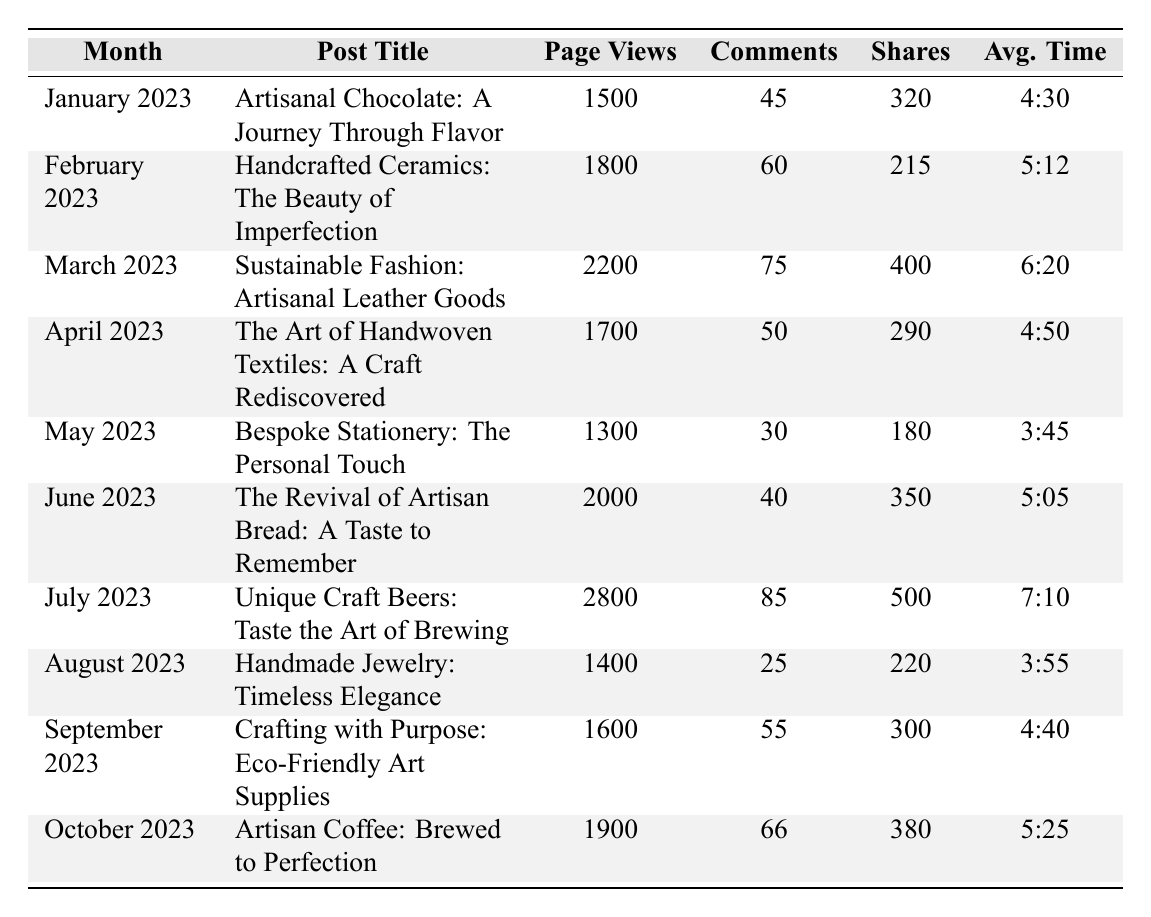What was the post with the highest page views? The post with the highest page views is "Unique Craft Beers: Taste the Art of Brewing," which had 2800 page views.
Answer: Unique Craft Beers: Taste the Art of Brewing How many shares did the "Sustainable Fashion: Artisanal Leather Goods" post receive? The "Sustainable Fashion: Artisanal Leather Goods" post received 400 shares according to the table.
Answer: 400 shares Which month had the lowest average time spent on blog posts? To find the month with the lowest average time spent, we compare the average times: January (4:30), February (5:12), March (6:20), April (4:50), May (3:45), June (5:05), July (7:10), August (3:55), September (4:40), October (5:25). May has the lowest time at 3:45.
Answer: May 2023 What is the total number of comments across all posts in June 2023 and July 2023? The comments for June 2023 and July 2023 are 40 and 85, respectively. Adding them gives 40 + 85 = 125 comments.
Answer: 125 comments Is the number of shares for "The Art of Handwoven Textiles: A Craft Rediscovered" more than 300? The shares for "The Art of Handwoven Textiles: A Craft Rediscovered" are 290, which is not more than 300.
Answer: No Which post had the highest engagement in terms of total interactions (sum of page views, comments, and shares) in October 2023? For October 2023, total interactions are calculated as follows: Page Views (1900) + Comments (66) + Shares (380) = 2346. This is the only data point for October, thus it's the highest by default for that month.
Answer: Artisan Coffee: Brewed to Perfection What was the average number of page views for the first half of 2023 (January to June)? The page views for the first half of 2023 are: January (1500), February (1800), March (2200), April (1700), May (1300), June (2000). The sum is 1500 + 1800 + 2200 + 1700 + 1300 + 2000 = 11500. The average is 11500/6 ≈ 1916.67.
Answer: Approximately 1917 Which post has the second-highest number of comments overall? The first-highest is July (85 comments), and the second-highest is March (75 comments). Thus, March has the second-highest comments overall.
Answer: Sustainable Fashion: Artisanal Leather Goods What is the median average time spent across all posts? The average times can be converted to minutes: 4:30 (4.5), 5:12 (5.2), 6:20 (6.33), 4:50 (4.83), 3:45 (3.75), 5:05 (5.08), 7:10 (7.17), 3:55 (3.92), 4:40 (4.67), 5:25 (5.42). Sorting these: 3.75, 3.92, 4.5, 4.67, 4.83, 5.08, 5.2, 5.42, 6.33, 7.17. The median (middle value) is the average of the 5th and 6th values: (4.83 + 5.08) / 2 ≈ 4.96 or 4:58.
Answer: 4:58 Was the number of page views for "Handmade Jewelry: Timeless Elegance" lower than that for "Bespoke Stationery: The Personal Touch"? Yes, "Handmade Jewelry: Timeless Elegance" had 1400 page views compared to 1300 for "Bespoke Stationery."
Answer: Yes 